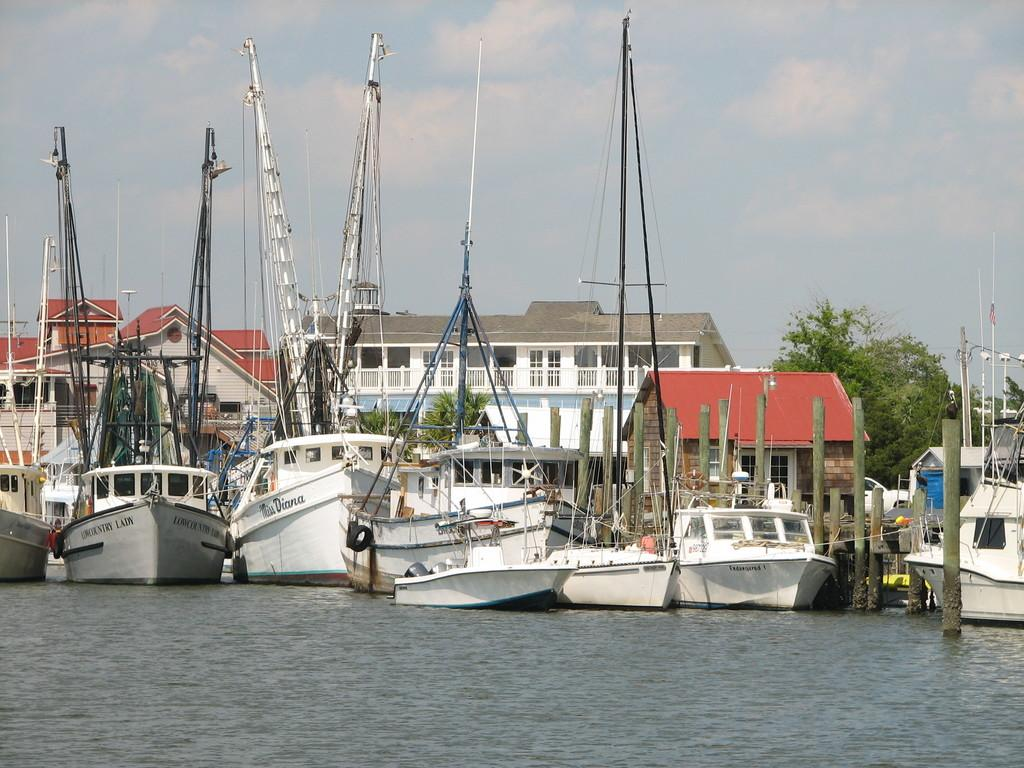What is the main subject of the image? The main subject of the image is a group of boats. What features do the boats have? The boats have poles and wires. Where are the boats located? The boats are in a large water body. What else can be seen in the image besides the boats? There are poles, buildings with windows, trees, and a cloudy sky visible in the image. What type of paper is being used to create a frame around the boats in the image? There is no paper or frame present in the image; it is a photograph of boats in a water body with other elements visible in the background. 